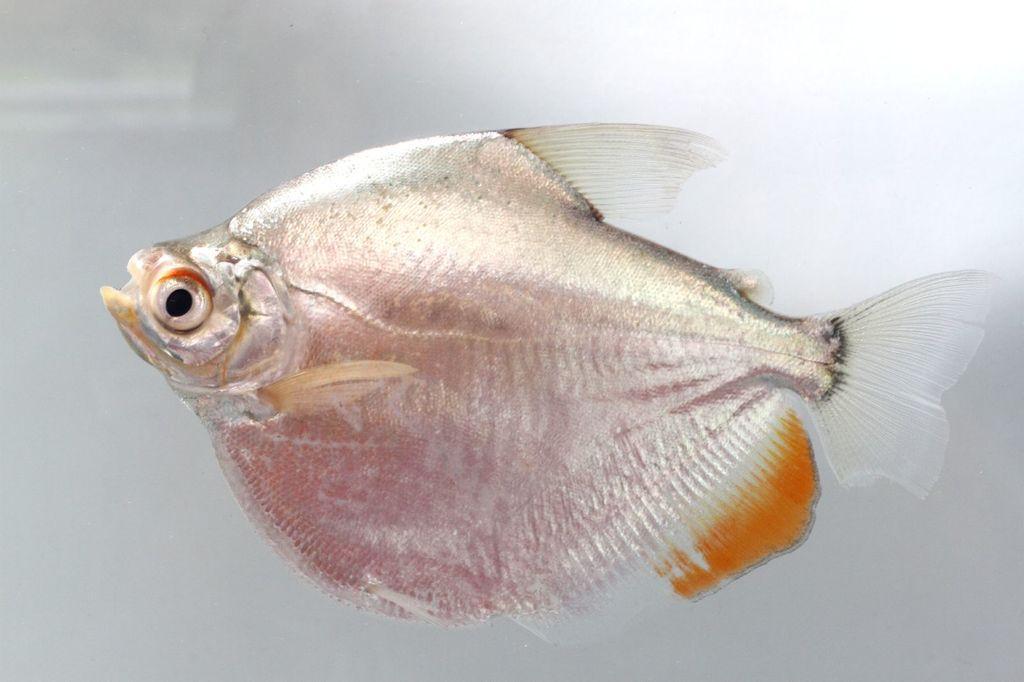Describe this image in one or two sentences. In this image we can see a fish. 